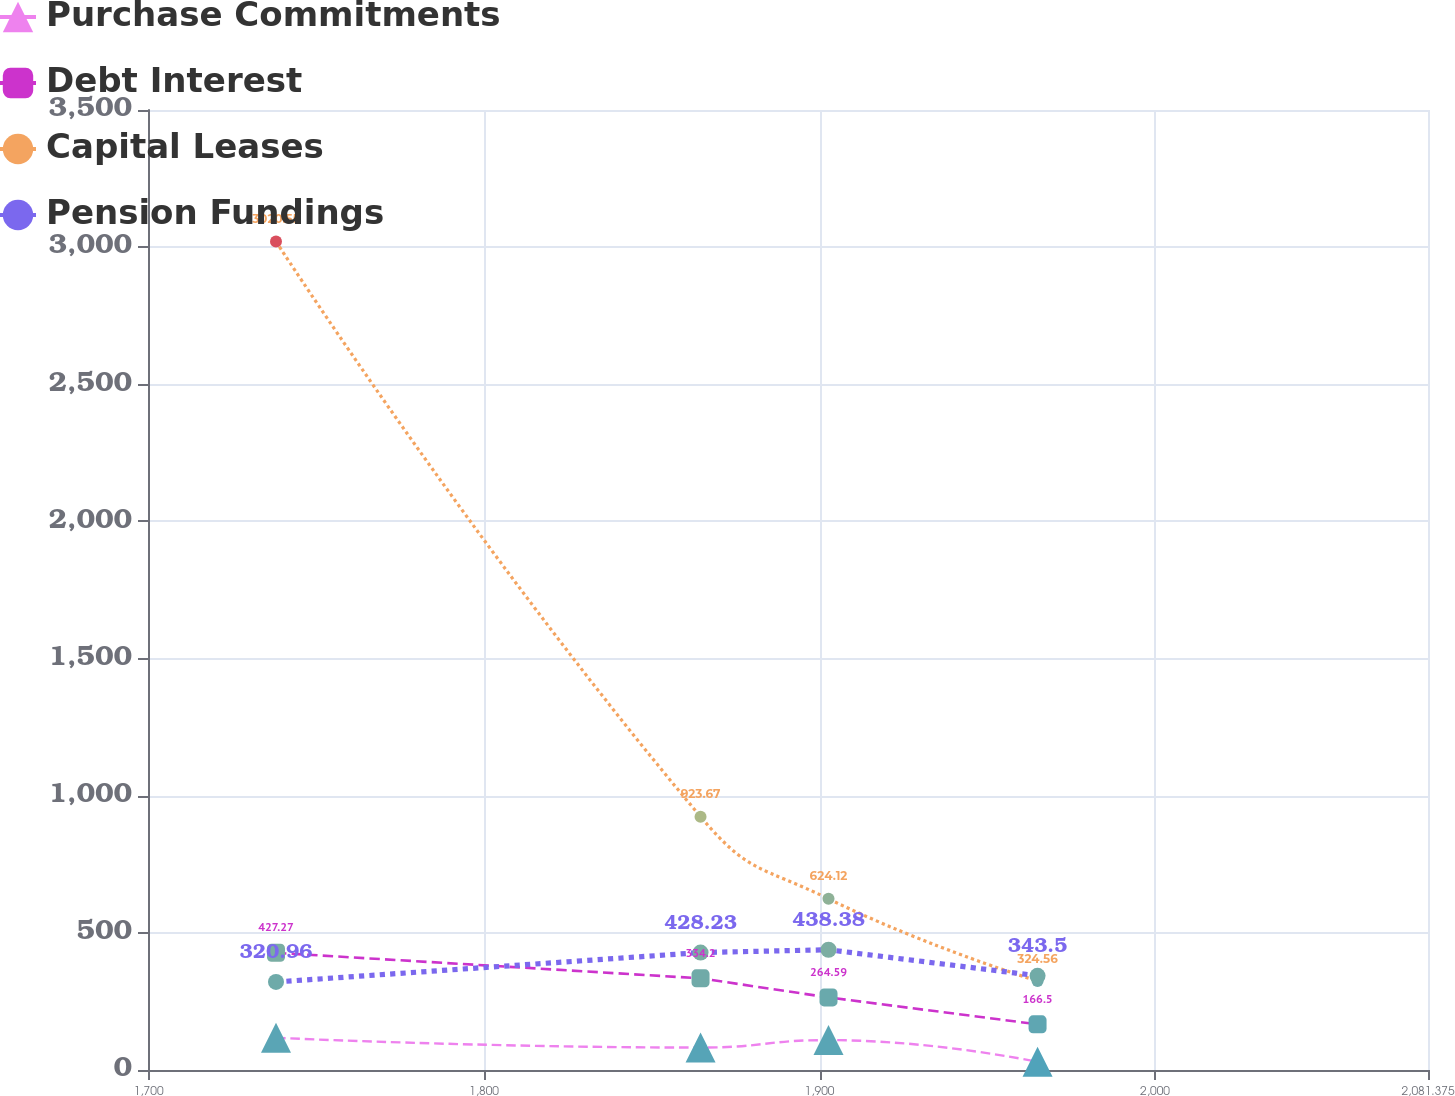Convert chart to OTSL. <chart><loc_0><loc_0><loc_500><loc_500><line_chart><ecel><fcel>Purchase Commitments<fcel>Debt Interest<fcel>Capital Leases<fcel>Pension Fundings<nl><fcel>1737.98<fcel>117.41<fcel>427.27<fcel>3020.55<fcel>320.96<nl><fcel>1864.53<fcel>81.85<fcel>334.2<fcel>923.67<fcel>428.23<nl><fcel>1902.68<fcel>109<fcel>264.59<fcel>624.12<fcel>438.38<nl><fcel>1964.99<fcel>29.78<fcel>166.5<fcel>324.56<fcel>343.5<nl><fcel>2119.53<fcel>38.19<fcel>134.83<fcel>25<fcel>418.08<nl></chart> 